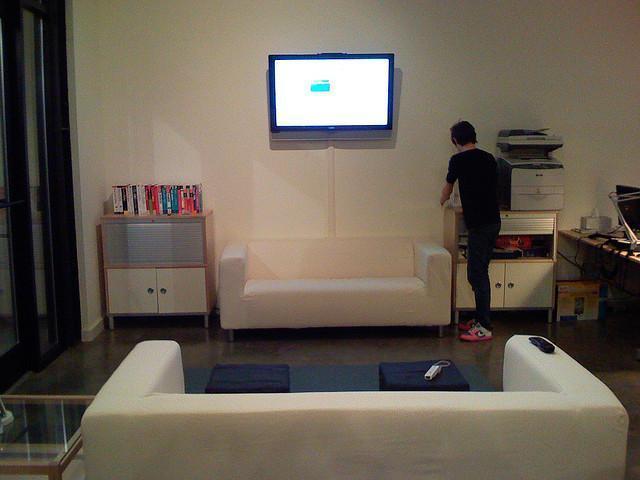How many couches are there?
Give a very brief answer. 2. 